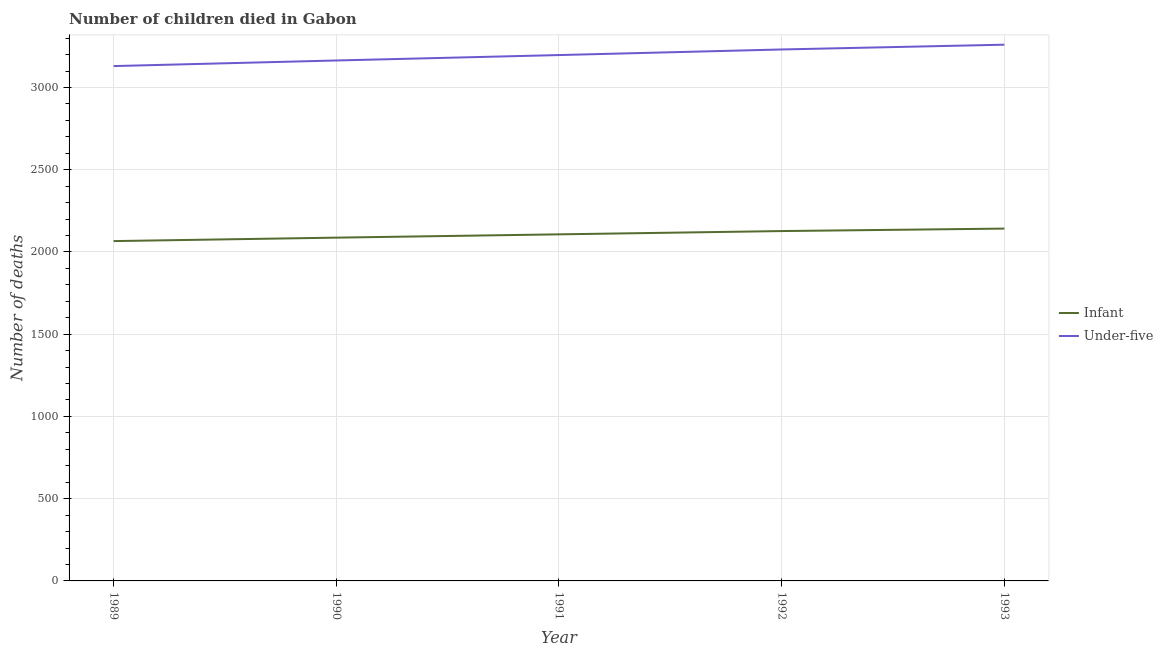Does the line corresponding to number of under-five deaths intersect with the line corresponding to number of infant deaths?
Make the answer very short. No. Is the number of lines equal to the number of legend labels?
Ensure brevity in your answer.  Yes. What is the number of infant deaths in 1989?
Your answer should be very brief. 2066. Across all years, what is the maximum number of under-five deaths?
Offer a very short reply. 3260. Across all years, what is the minimum number of under-five deaths?
Ensure brevity in your answer.  3130. What is the total number of infant deaths in the graph?
Give a very brief answer. 1.05e+04. What is the difference between the number of infant deaths in 1990 and that in 1992?
Provide a succinct answer. -40. What is the difference between the number of infant deaths in 1993 and the number of under-five deaths in 1992?
Provide a succinct answer. -1089. What is the average number of infant deaths per year?
Offer a very short reply. 2105.8. In the year 1993, what is the difference between the number of infant deaths and number of under-five deaths?
Provide a short and direct response. -1118. What is the ratio of the number of infant deaths in 1990 to that in 1991?
Your answer should be compact. 0.99. Is the number of infant deaths in 1990 less than that in 1991?
Your answer should be very brief. Yes. Is the difference between the number of under-five deaths in 1991 and 1993 greater than the difference between the number of infant deaths in 1991 and 1993?
Provide a succinct answer. No. What is the difference between the highest and the lowest number of under-five deaths?
Offer a terse response. 130. Is the sum of the number of infant deaths in 1992 and 1993 greater than the maximum number of under-five deaths across all years?
Your answer should be compact. Yes. Is the number of infant deaths strictly greater than the number of under-five deaths over the years?
Give a very brief answer. No. What is the difference between two consecutive major ticks on the Y-axis?
Ensure brevity in your answer.  500. Are the values on the major ticks of Y-axis written in scientific E-notation?
Offer a terse response. No. Does the graph contain any zero values?
Your answer should be very brief. No. Does the graph contain grids?
Provide a succinct answer. Yes. How are the legend labels stacked?
Make the answer very short. Vertical. What is the title of the graph?
Make the answer very short. Number of children died in Gabon. Does "Overweight" appear as one of the legend labels in the graph?
Provide a succinct answer. No. What is the label or title of the Y-axis?
Your answer should be very brief. Number of deaths. What is the Number of deaths of Infant in 1989?
Provide a succinct answer. 2066. What is the Number of deaths of Under-five in 1989?
Your answer should be compact. 3130. What is the Number of deaths of Infant in 1990?
Provide a succinct answer. 2087. What is the Number of deaths in Under-five in 1990?
Offer a terse response. 3164. What is the Number of deaths of Infant in 1991?
Your response must be concise. 2107. What is the Number of deaths of Under-five in 1991?
Your answer should be very brief. 3197. What is the Number of deaths of Infant in 1992?
Your answer should be compact. 2127. What is the Number of deaths in Under-five in 1992?
Provide a short and direct response. 3231. What is the Number of deaths in Infant in 1993?
Give a very brief answer. 2142. What is the Number of deaths of Under-five in 1993?
Ensure brevity in your answer.  3260. Across all years, what is the maximum Number of deaths of Infant?
Your response must be concise. 2142. Across all years, what is the maximum Number of deaths of Under-five?
Provide a short and direct response. 3260. Across all years, what is the minimum Number of deaths of Infant?
Make the answer very short. 2066. Across all years, what is the minimum Number of deaths in Under-five?
Keep it short and to the point. 3130. What is the total Number of deaths of Infant in the graph?
Make the answer very short. 1.05e+04. What is the total Number of deaths of Under-five in the graph?
Make the answer very short. 1.60e+04. What is the difference between the Number of deaths in Under-five in 1989 and that in 1990?
Keep it short and to the point. -34. What is the difference between the Number of deaths of Infant in 1989 and that in 1991?
Offer a very short reply. -41. What is the difference between the Number of deaths in Under-five in 1989 and that in 1991?
Keep it short and to the point. -67. What is the difference between the Number of deaths of Infant in 1989 and that in 1992?
Ensure brevity in your answer.  -61. What is the difference between the Number of deaths in Under-five in 1989 and that in 1992?
Make the answer very short. -101. What is the difference between the Number of deaths in Infant in 1989 and that in 1993?
Ensure brevity in your answer.  -76. What is the difference between the Number of deaths in Under-five in 1989 and that in 1993?
Make the answer very short. -130. What is the difference between the Number of deaths of Under-five in 1990 and that in 1991?
Offer a terse response. -33. What is the difference between the Number of deaths in Infant in 1990 and that in 1992?
Give a very brief answer. -40. What is the difference between the Number of deaths in Under-five in 1990 and that in 1992?
Offer a very short reply. -67. What is the difference between the Number of deaths of Infant in 1990 and that in 1993?
Your answer should be compact. -55. What is the difference between the Number of deaths of Under-five in 1990 and that in 1993?
Make the answer very short. -96. What is the difference between the Number of deaths in Under-five in 1991 and that in 1992?
Your response must be concise. -34. What is the difference between the Number of deaths of Infant in 1991 and that in 1993?
Your response must be concise. -35. What is the difference between the Number of deaths in Under-five in 1991 and that in 1993?
Keep it short and to the point. -63. What is the difference between the Number of deaths in Infant in 1992 and that in 1993?
Make the answer very short. -15. What is the difference between the Number of deaths in Under-five in 1992 and that in 1993?
Keep it short and to the point. -29. What is the difference between the Number of deaths of Infant in 1989 and the Number of deaths of Under-five in 1990?
Provide a succinct answer. -1098. What is the difference between the Number of deaths in Infant in 1989 and the Number of deaths in Under-five in 1991?
Provide a short and direct response. -1131. What is the difference between the Number of deaths of Infant in 1989 and the Number of deaths of Under-five in 1992?
Provide a succinct answer. -1165. What is the difference between the Number of deaths in Infant in 1989 and the Number of deaths in Under-five in 1993?
Provide a succinct answer. -1194. What is the difference between the Number of deaths of Infant in 1990 and the Number of deaths of Under-five in 1991?
Your answer should be compact. -1110. What is the difference between the Number of deaths of Infant in 1990 and the Number of deaths of Under-five in 1992?
Ensure brevity in your answer.  -1144. What is the difference between the Number of deaths in Infant in 1990 and the Number of deaths in Under-five in 1993?
Keep it short and to the point. -1173. What is the difference between the Number of deaths in Infant in 1991 and the Number of deaths in Under-five in 1992?
Offer a very short reply. -1124. What is the difference between the Number of deaths in Infant in 1991 and the Number of deaths in Under-five in 1993?
Offer a terse response. -1153. What is the difference between the Number of deaths of Infant in 1992 and the Number of deaths of Under-five in 1993?
Offer a terse response. -1133. What is the average Number of deaths in Infant per year?
Your answer should be compact. 2105.8. What is the average Number of deaths of Under-five per year?
Offer a terse response. 3196.4. In the year 1989, what is the difference between the Number of deaths in Infant and Number of deaths in Under-five?
Provide a short and direct response. -1064. In the year 1990, what is the difference between the Number of deaths of Infant and Number of deaths of Under-five?
Offer a terse response. -1077. In the year 1991, what is the difference between the Number of deaths of Infant and Number of deaths of Under-five?
Offer a terse response. -1090. In the year 1992, what is the difference between the Number of deaths of Infant and Number of deaths of Under-five?
Provide a short and direct response. -1104. In the year 1993, what is the difference between the Number of deaths of Infant and Number of deaths of Under-five?
Make the answer very short. -1118. What is the ratio of the Number of deaths in Infant in 1989 to that in 1990?
Provide a succinct answer. 0.99. What is the ratio of the Number of deaths in Under-five in 1989 to that in 1990?
Give a very brief answer. 0.99. What is the ratio of the Number of deaths of Infant in 1989 to that in 1991?
Offer a very short reply. 0.98. What is the ratio of the Number of deaths in Under-five in 1989 to that in 1991?
Your response must be concise. 0.98. What is the ratio of the Number of deaths in Infant in 1989 to that in 1992?
Your answer should be compact. 0.97. What is the ratio of the Number of deaths of Under-five in 1989 to that in 1992?
Provide a succinct answer. 0.97. What is the ratio of the Number of deaths in Infant in 1989 to that in 1993?
Give a very brief answer. 0.96. What is the ratio of the Number of deaths of Under-five in 1989 to that in 1993?
Keep it short and to the point. 0.96. What is the ratio of the Number of deaths of Under-five in 1990 to that in 1991?
Offer a very short reply. 0.99. What is the ratio of the Number of deaths in Infant in 1990 to that in 1992?
Offer a very short reply. 0.98. What is the ratio of the Number of deaths of Under-five in 1990 to that in 1992?
Your answer should be very brief. 0.98. What is the ratio of the Number of deaths in Infant in 1990 to that in 1993?
Your response must be concise. 0.97. What is the ratio of the Number of deaths in Under-five in 1990 to that in 1993?
Give a very brief answer. 0.97. What is the ratio of the Number of deaths in Infant in 1991 to that in 1992?
Make the answer very short. 0.99. What is the ratio of the Number of deaths of Under-five in 1991 to that in 1992?
Offer a very short reply. 0.99. What is the ratio of the Number of deaths in Infant in 1991 to that in 1993?
Make the answer very short. 0.98. What is the ratio of the Number of deaths of Under-five in 1991 to that in 1993?
Your response must be concise. 0.98. What is the ratio of the Number of deaths of Infant in 1992 to that in 1993?
Offer a terse response. 0.99. What is the difference between the highest and the second highest Number of deaths of Infant?
Ensure brevity in your answer.  15. What is the difference between the highest and the lowest Number of deaths in Infant?
Provide a succinct answer. 76. What is the difference between the highest and the lowest Number of deaths in Under-five?
Offer a very short reply. 130. 